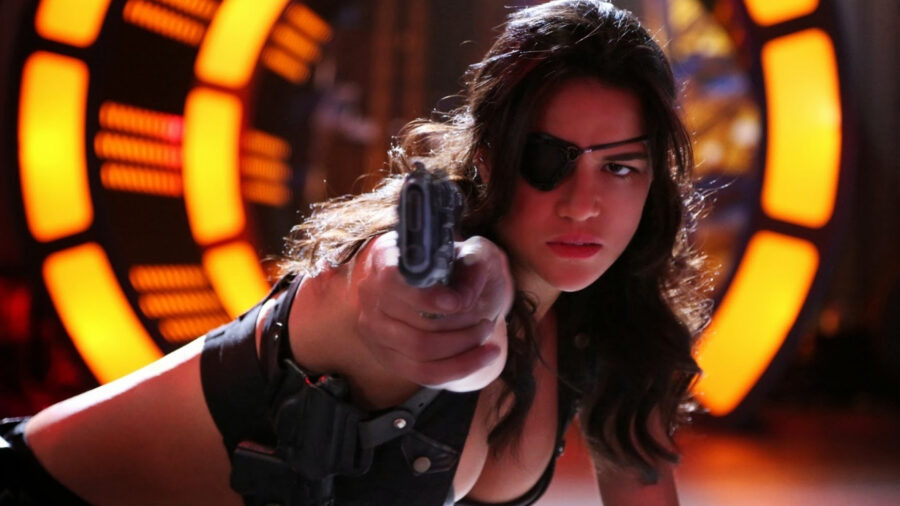Describe the scene in the photo. The scene is highly dynamic and charged with tension. A woman, in a black tank top and an eyepatch, aims a gun directly at the viewer, her expression focused and determined. The backdrop is composed of brightly glowing orange and yellow lights, evoking a sense of futuristic or high-tech environment. The overall composition of the image suggests that she might be in the middle of an intense action sequence or a climactic confrontation. Can you explain the significance of the eyepatch? The eyepatch worn by the woman in the image could signify that she is a seasoned fighter who has endured and survived past battles, which possibly resulted in her losing an eye. This element enhances her character's backstory, adding depth and a sense of experience and resilience. It complements her tough demeanor and suggests a no-nonsense attitude shaped by her past experiences. 